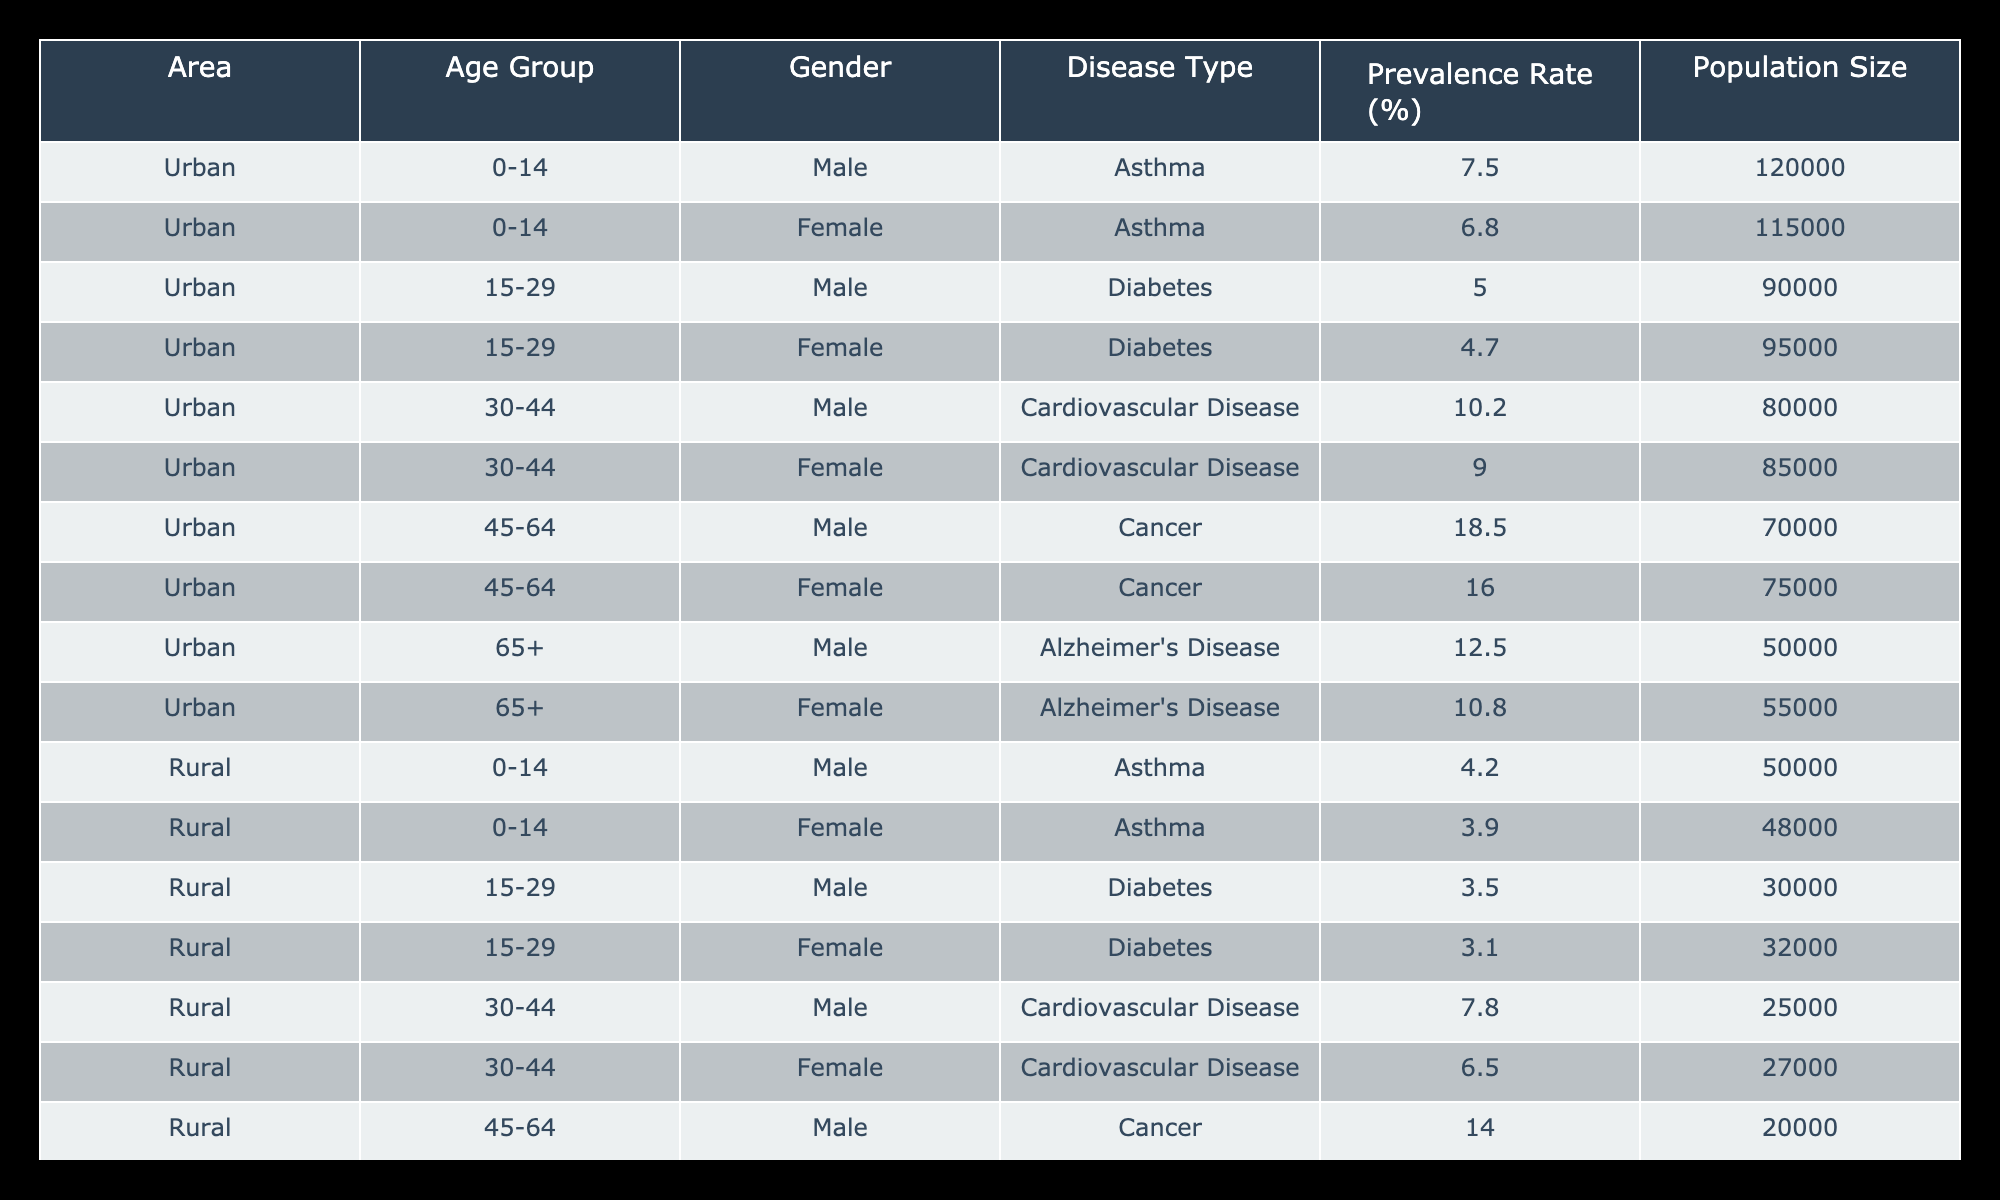What is the prevalence rate of asthma for males in urban areas? Looking at the "Urban" section under the age group "0-14", the prevalence rate for males is listed as 7.5%.
Answer: 7.5% What is the total population size of females aged 15-29 in rural areas? In the rural section, we look under the age group "15-29" for females. The population sizes listed are 32,000.
Answer: 32,000 Does the prevalence rate of diabetes differ between genders in urban areas? For "Urban" areas, the prevalence rate for males is 5.0% and for females is 4.7%. Since these values are different, we can conclude that there is a difference.
Answer: Yes What is the difference in the prevalence rates of cardiovascular disease between males and females in rural areas? In rural areas, the prevalence rate for males in the age group "30-44" is 7.8% and for females is 6.5%. The difference is calculated as 7.8% - 6.5% = 1.3%.
Answer: 1.3% What is the average prevalence rate of Alzheimer's disease in urban versus rural areas for males? In urban areas, the prevalence for males is 12.5%, while in rural areas it is 8.0%. The average rate is calculated as (12.5% + 8.0%) / 2 = 10.25%.
Answer: 10.25% Is the prevalence of asthma higher in urban males compared to rural males? The prevalence of asthma for urban males is 7.5%, while for rural males it is 4.2%. Since 7.5% is greater than 4.2%, the answer is yes.
Answer: Yes What is the largest population size among urban females aged 45-64? In the urban section, the population size for females aged 45-64 is 75,000. Checking other age groups, this is the highest listed for urban females.
Answer: 75,000 What is the ratio of male to female prevalence rates for cancer in urban areas? In urban areas, the prevalence for males is 18.5% and for females is 16.0%. The ratio is calculated as 18.5% : 16.0%, which simplifies to approximately 1.16:1.
Answer: 1.16:1 How does the prevalence of asthma in rural females compare to urban females? In rural areas, the prevalence for females is 3.9%, while in urban areas it is 6.8%. Since 3.9% is less than 6.8%, we conclude that urban females have a higher prevalence.
Answer: Urban females have a higher prevalence 